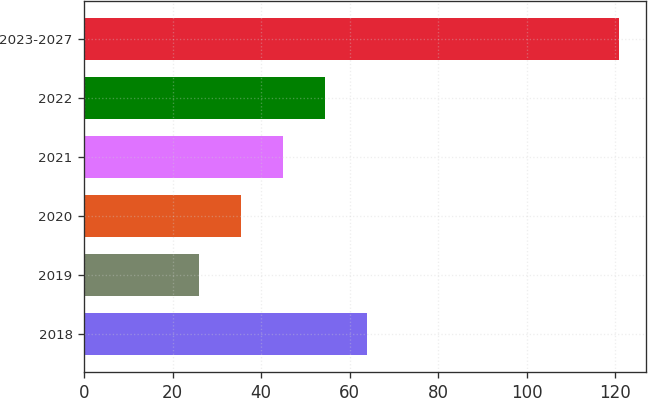Convert chart to OTSL. <chart><loc_0><loc_0><loc_500><loc_500><bar_chart><fcel>2018<fcel>2019<fcel>2020<fcel>2021<fcel>2022<fcel>2023-2027<nl><fcel>64<fcel>26<fcel>35.5<fcel>45<fcel>54.5<fcel>121<nl></chart> 